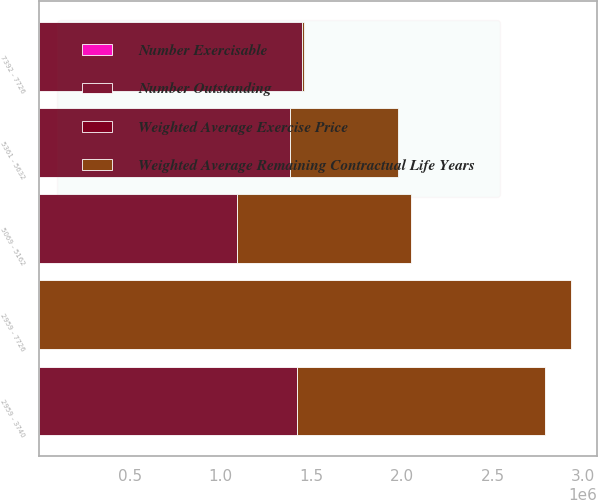<chart> <loc_0><loc_0><loc_500><loc_500><stacked_bar_chart><ecel><fcel>2959 - 3740<fcel>5069 - 5162<fcel>5361 - 5632<fcel>7392 - 7726<fcel>2959 - 7726<nl><fcel>Number Outstanding<fcel>1.42127e+06<fcel>1.0907e+06<fcel>1.38458e+06<fcel>1.45152e+06<fcel>77.24<nl><fcel>Number Exercisable<fcel>2.2<fcel>3.69<fcel>4.63<fcel>7.23<fcel>4.89<nl><fcel>Weighted Average Exercise Price<fcel>34.54<fcel>50.7<fcel>53.65<fcel>77.24<fcel>53.59<nl><fcel>Weighted Average Remaining Contractual Life Years<fcel>1.36669e+06<fcel>958463<fcel>594184<fcel>9643<fcel>2.92898e+06<nl></chart> 